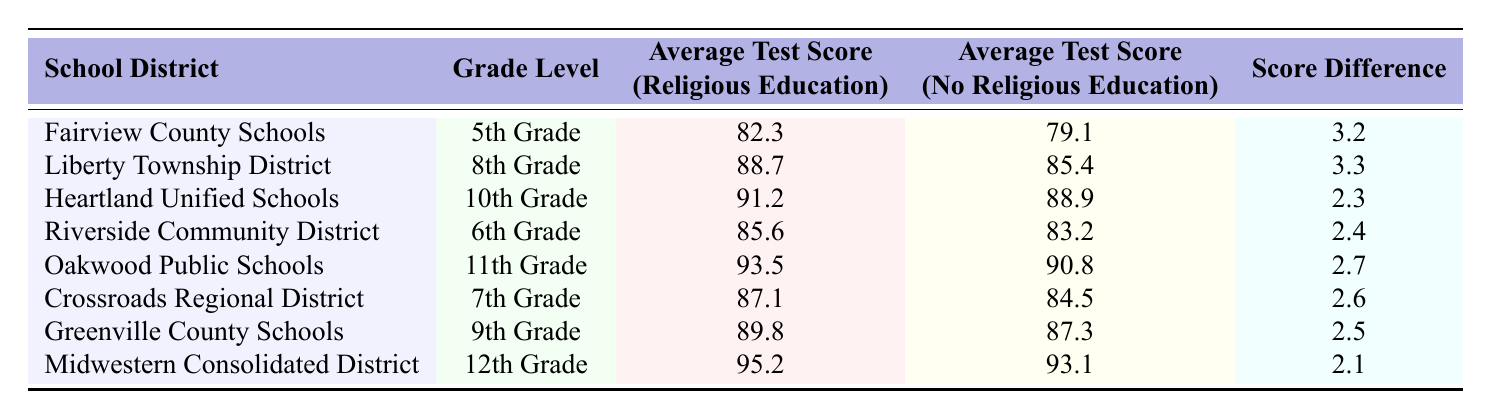What is the highest average test score for students who took religious education? Looking at the "Average Test Score (Religious Education)" column, the highest value is 95.2 from Midwestern Consolidated District.
Answer: 95.2 Which school district had the lowest difference in average test scores between students who took religious education and those who did not? To find the lowest score difference, we check the "Score Difference" column and find that Midwestern Consolidated District had the lowest difference of 2.1.
Answer: Midwestern Consolidated District In which grade level did students with religious education score the highest? The highest average score for students who took religious education is 95.2 in the 12th grade at Midwestern Consolidated District.
Answer: 12th Grade What is the combined average test score for students who took religious education across all grade levels listed? To find the combined average, sum up all the scores (82.3 + 88.7 + 91.2 + 85.6 + 93.5 + 87.1 + 89.8 + 95.2 =  818.4) and divide by the total number of grade levels (8). Thus, 818.4/8 = 102.3.
Answer: 102.3 Did any school district have a score difference of less than 2.5? By reviewing the "Score Difference" column, we see that Heartland Unified Schools (2.3) and Midwestern Consolidated District (2.1) both have differences that are less than 2.5.
Answer: Yes Which grade level had both the highest and the lowest average test scores for students without religious education? The highest score is 93.1 in the 12th grade at Midwestern Consolidated District, and the lowest is 79.1 in the 5th grade at Fairview County Schools.
Answer: 12th Grade; 5th Grade How many districts show an average test score for religious education that is above 90? Checking the "Average Test Score (Religious Education)", we find that Midwestern Consolidated District (95.2), Oakwood Public Schools (93.5), Heartland Unified Schools (91.2) all show scores above 90, totaling 3 districts.
Answer: 3 Is the average test score for students with religious education consistently higher compared to those without? Examining the scores, all entries in "Average Test Score (Religious Education)" exceed those in "Average Test Score (No Religious Education)", indicating consistency.
Answer: Yes What is the average score difference for the 6th and 12th grades combined? The differences for the 6th and 12th grades are 2.4 and 2.1 respectively. To find the average, sum them (2.4 + 2.1 = 4.5) and divide by 2. The average difference is 4.5 / 2 = 2.25.
Answer: 2.25 